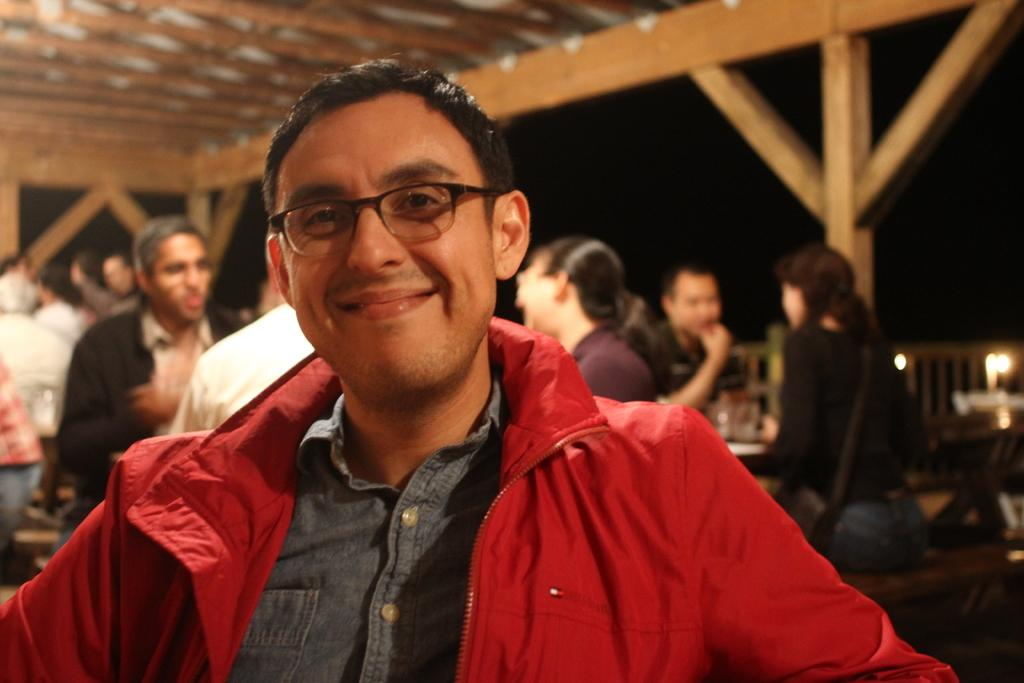What are the people in the image doing? The people in the image are sitting on benches. What objects are in front of the benches? There are tables in front of the benches. What can be seen on top of the tables? There are glasses on top of the tables. What is visible at the right side of the image? There are lights visible at the right side of the image. What type of crown is being worn by the person sitting on the bench? There is no person wearing a crown in the image. What is the purpose of the glasses on the table? The purpose of the glasses on the table cannot be determined from the image alone, as we do not know what they contain or what they are being used for. 